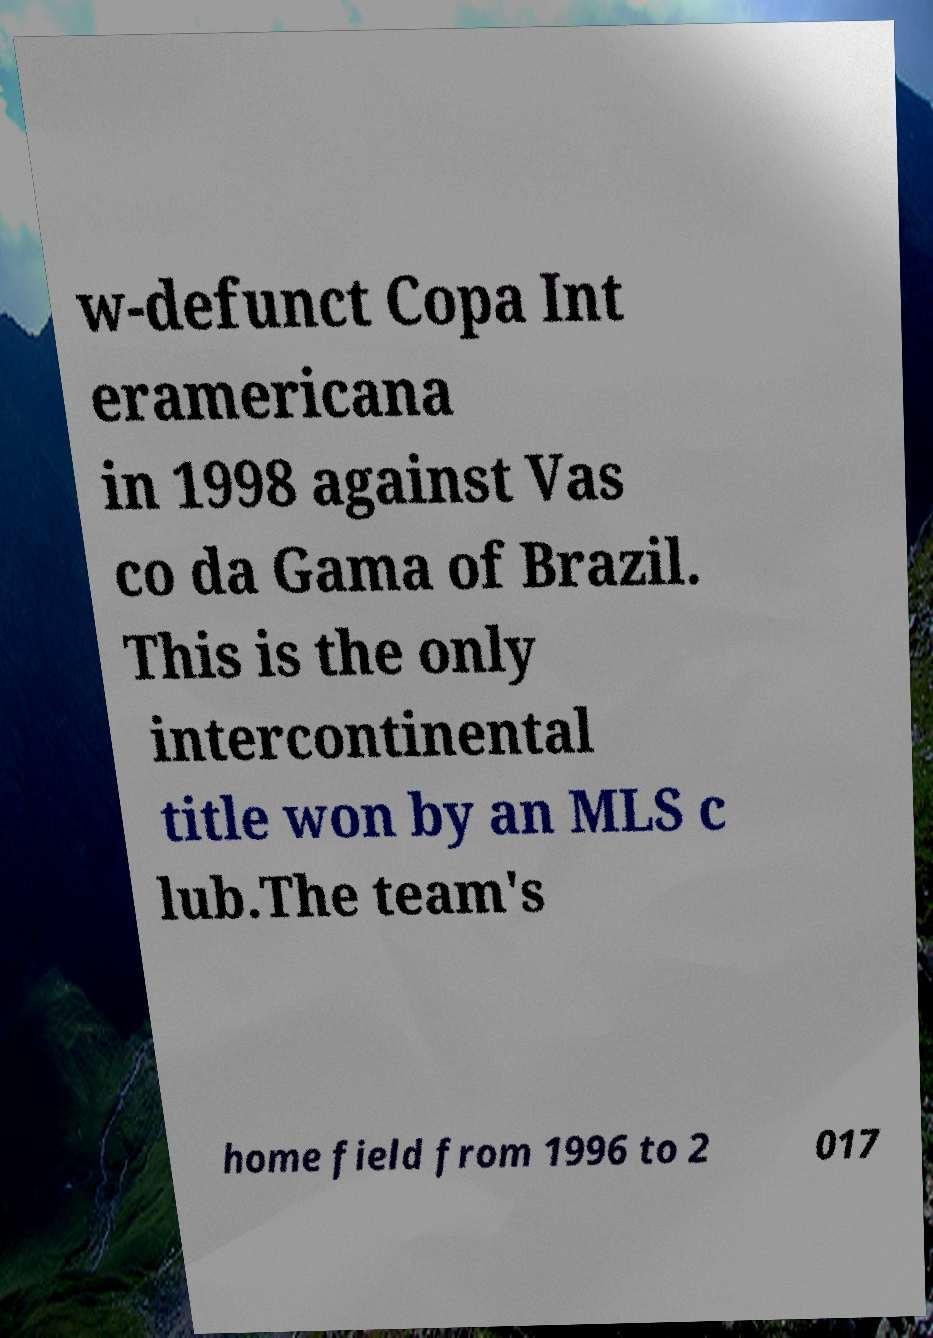Could you extract and type out the text from this image? w-defunct Copa Int eramericana in 1998 against Vas co da Gama of Brazil. This is the only intercontinental title won by an MLS c lub.The team's home field from 1996 to 2 017 